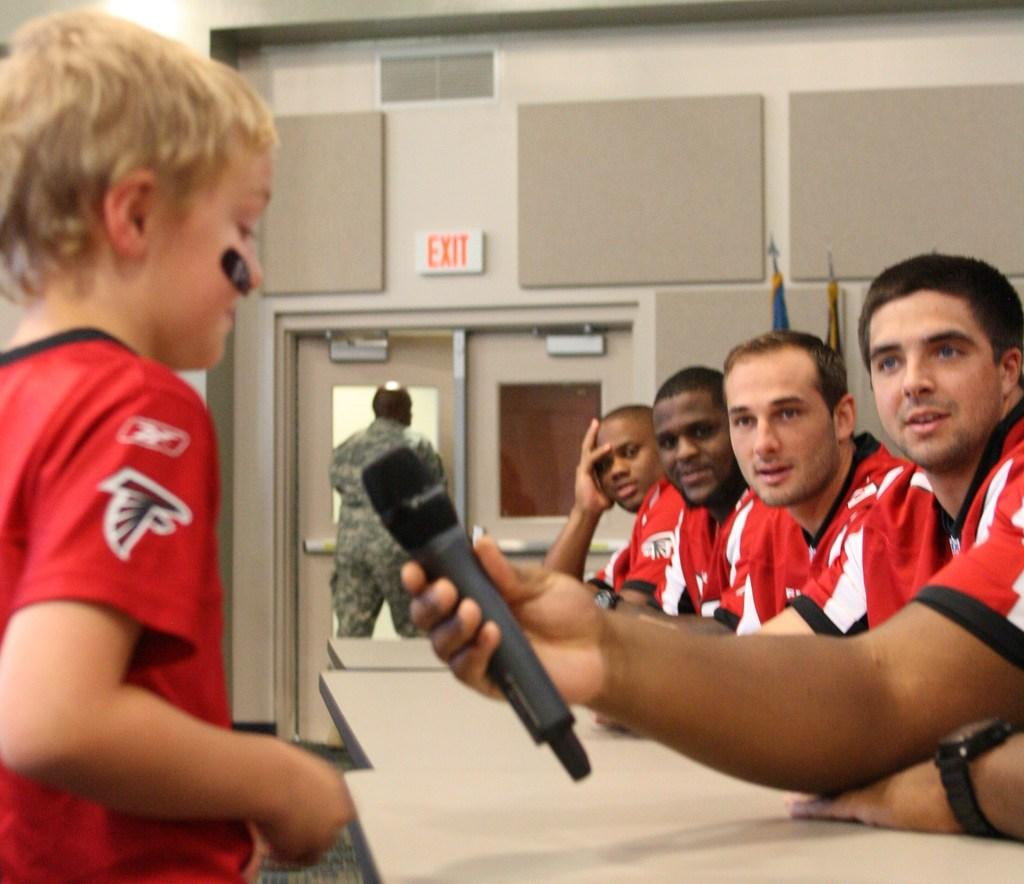<image>
Offer a succinct explanation of the picture presented. A young boy is talking into a microphone while a man in uniform leaves through a door marked Exit. 